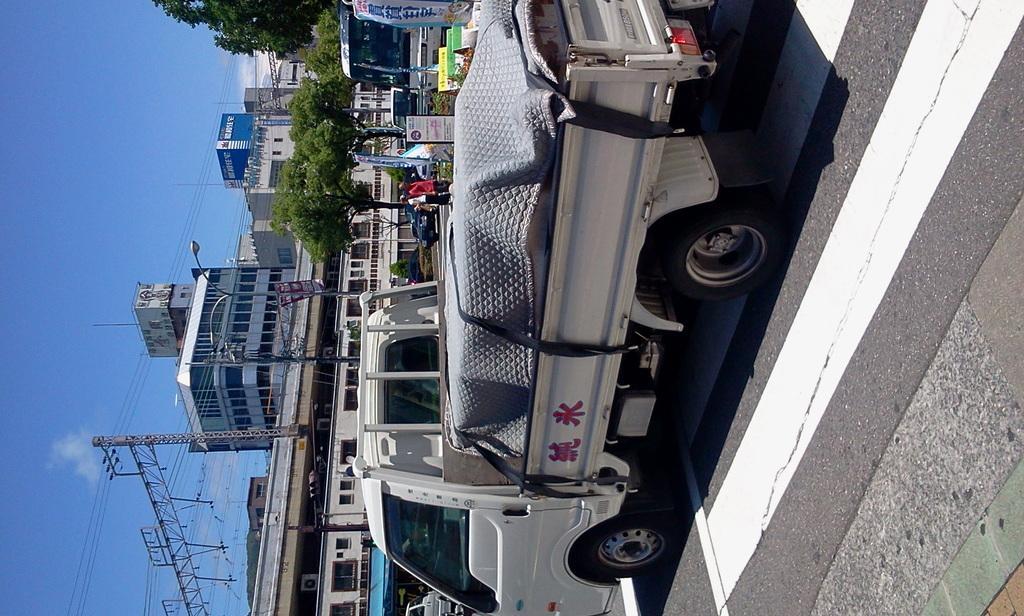Please provide a concise description of this image. In this image in the center there are vehicles, and some people are walking and also there are some boards, poles, street lights, plants. And on the right side of the image there is a walkway, and in the background there are some trees, buildings, tower, wires and on the left side of the image there is sky. 